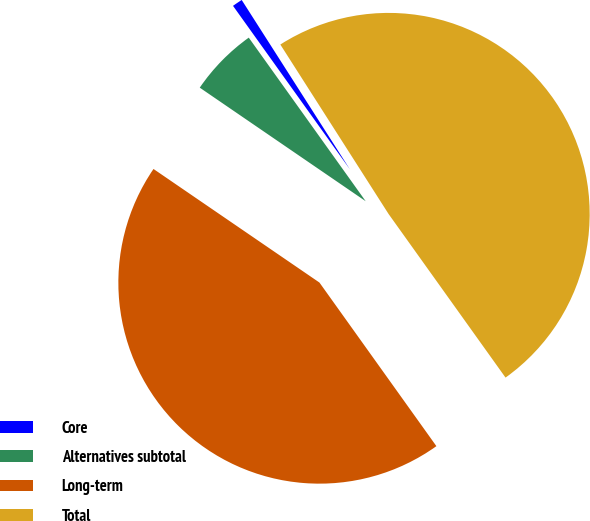<chart> <loc_0><loc_0><loc_500><loc_500><pie_chart><fcel>Core<fcel>Alternatives subtotal<fcel>Long-term<fcel>Total<nl><fcel>0.83%<fcel>5.57%<fcel>44.43%<fcel>49.17%<nl></chart> 